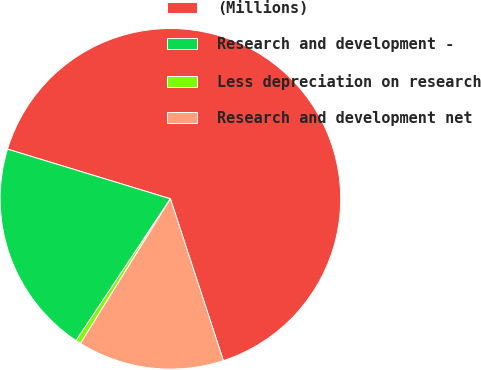Convert chart to OTSL. <chart><loc_0><loc_0><loc_500><loc_500><pie_chart><fcel>(Millions)<fcel>Research and development -<fcel>Less depreciation on research<fcel>Research and development net<nl><fcel>65.26%<fcel>20.37%<fcel>0.49%<fcel>13.89%<nl></chart> 